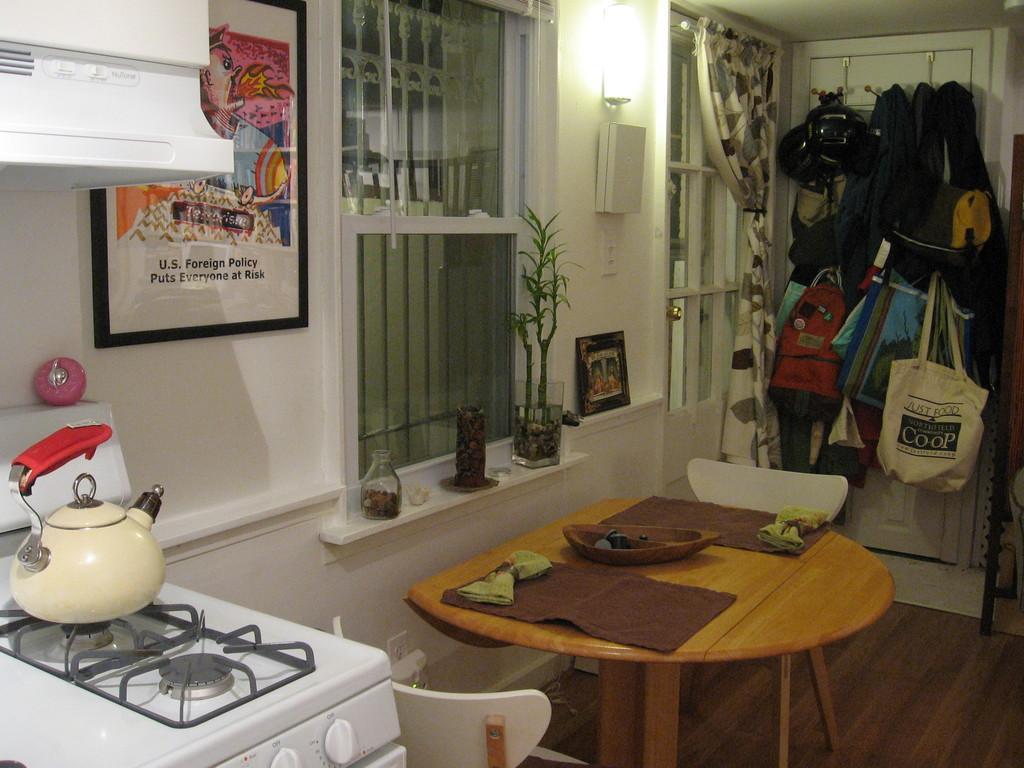Could you give a brief overview of what you see in this image? This is a picture taken inside view of a house,on left side i can see a stove and there is a bowl on the stove and there is a photo frame attached to the wall ,on the left side beside wall there is a window ,on the window there is a flower plant ,in front of the window there is a table ,on the table there are some objects m kept on the table. On the right corner i can see a bag attached to the door near to the window i can see a curtain attached to the window 